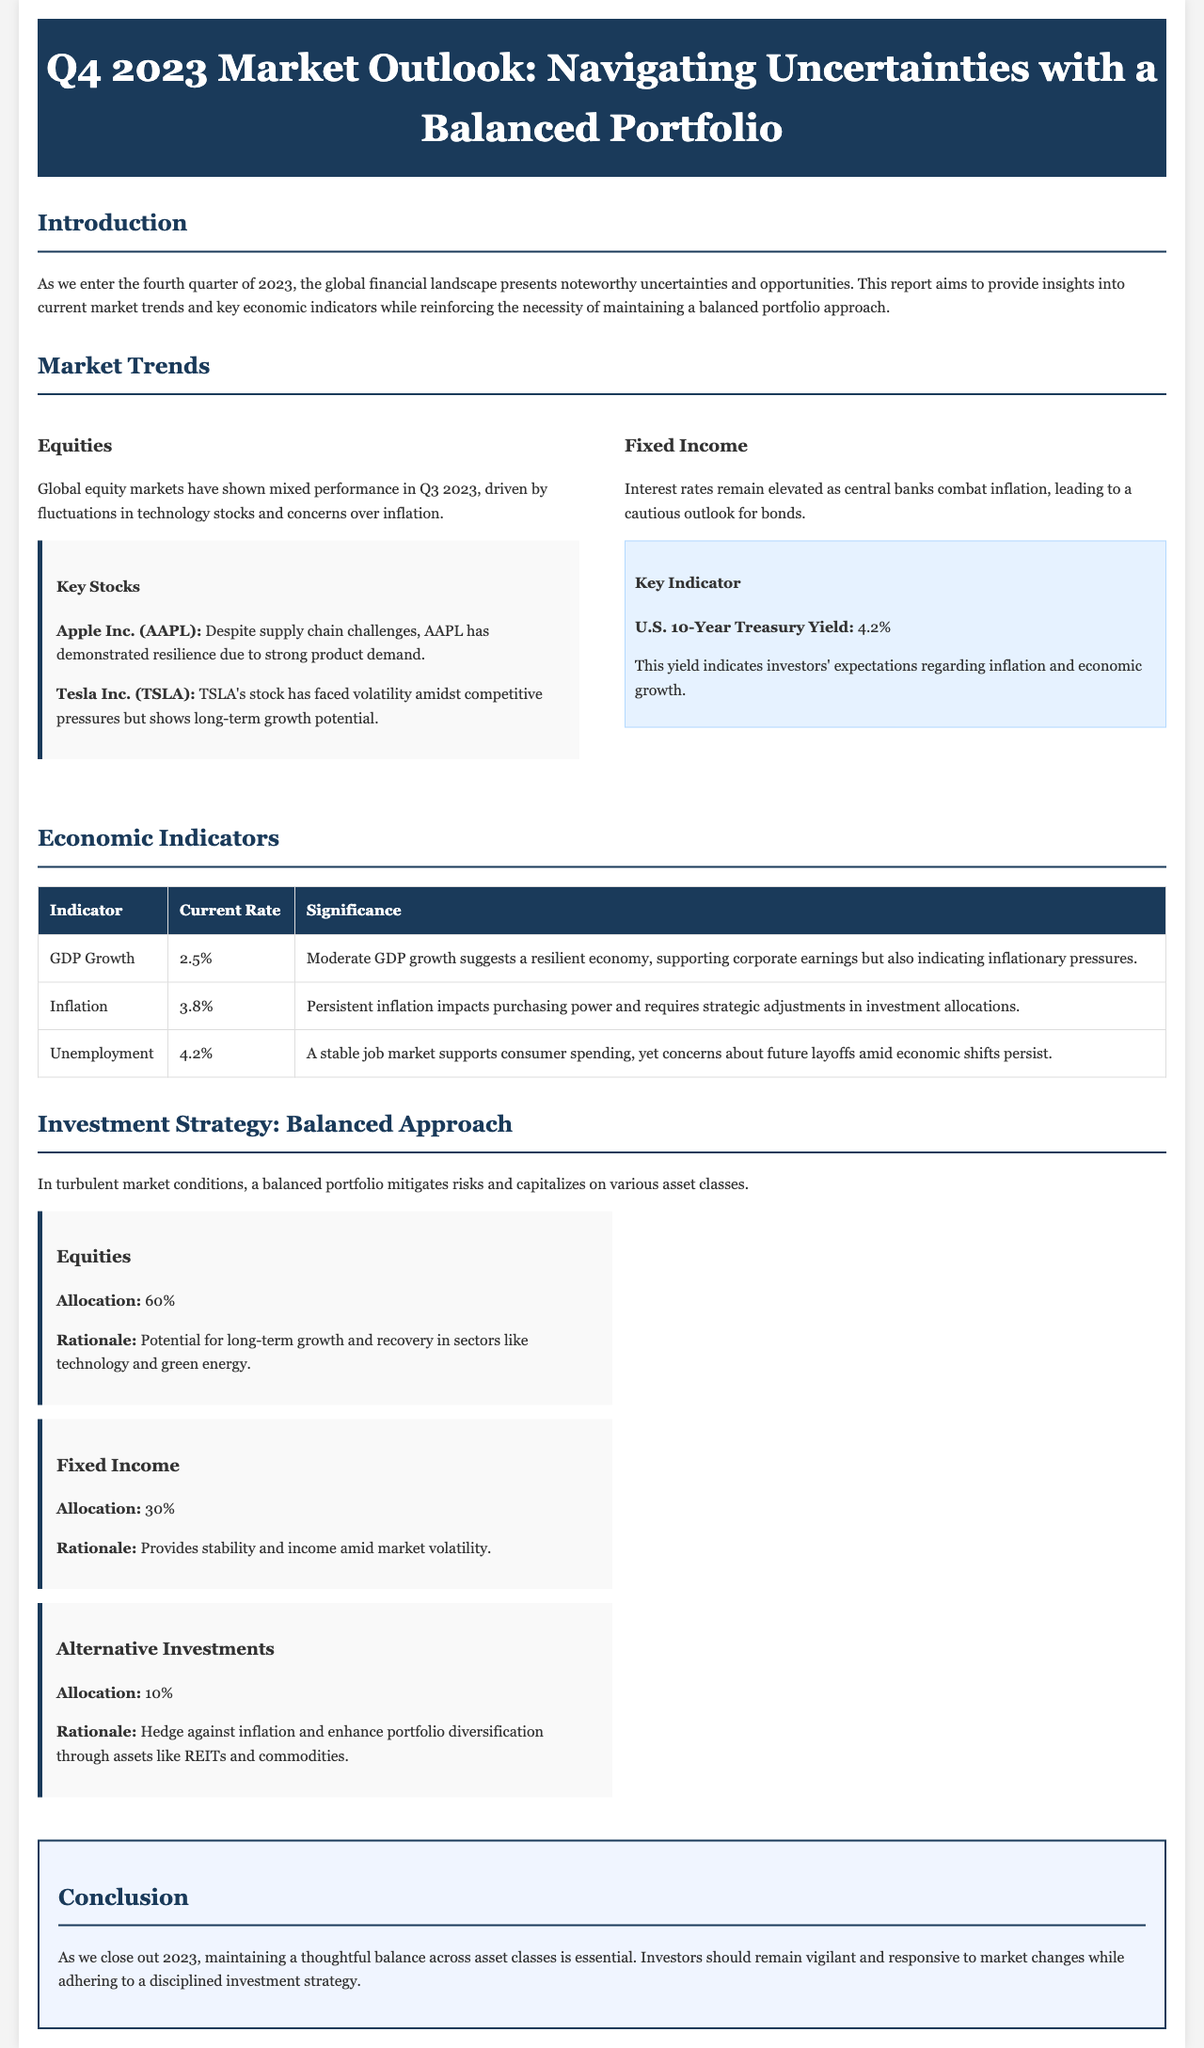what is the global equity market performance in Q3 2023? The document states that global equity markets have shown mixed performance in Q3 2023.
Answer: mixed performance what is the current U.S. 10-Year Treasury Yield? The document provides the current U.S. 10-Year Treasury Yield as 4.2%.
Answer: 4.2% what is the allocation percentage for Fixed Income in a balanced portfolio? The document specifies that the allocation for Fixed Income is 30%.
Answer: 30% what is the current inflation rate mentioned in the document? The document lists the current inflation rate as 3.8%.
Answer: 3.8% what are the two key stocks highlighted in the equities section? The document mentions Apple Inc. (AAPL) and Tesla Inc. (TSLA) as key stocks.
Answer: Apple Inc. (AAPL), Tesla Inc. (TSLA) what is the significance of moderate GDP growth according to the report? The document explains that moderate GDP growth suggests a resilient economy and supports corporate earnings but indicates inflationary pressures.
Answer: resilient economy why is a balanced portfolio emphasized in the document? The document emphasizes that a balanced portfolio mitigates risks and capitalizes on various asset classes amid turbulent market conditions.
Answer: mitigate risks what is the rationale for the 10% allocation to Alternative Investments? The document states that the rationale for Alternative Investments is to hedge against inflation and enhance portfolio diversification.
Answer: hedge against inflation what conclusion is drawn about maintaining asset class balance by the end of 2023? The conclusion drawn is that maintaining a thoughtful balance across asset classes is essential.
Answer: essential 